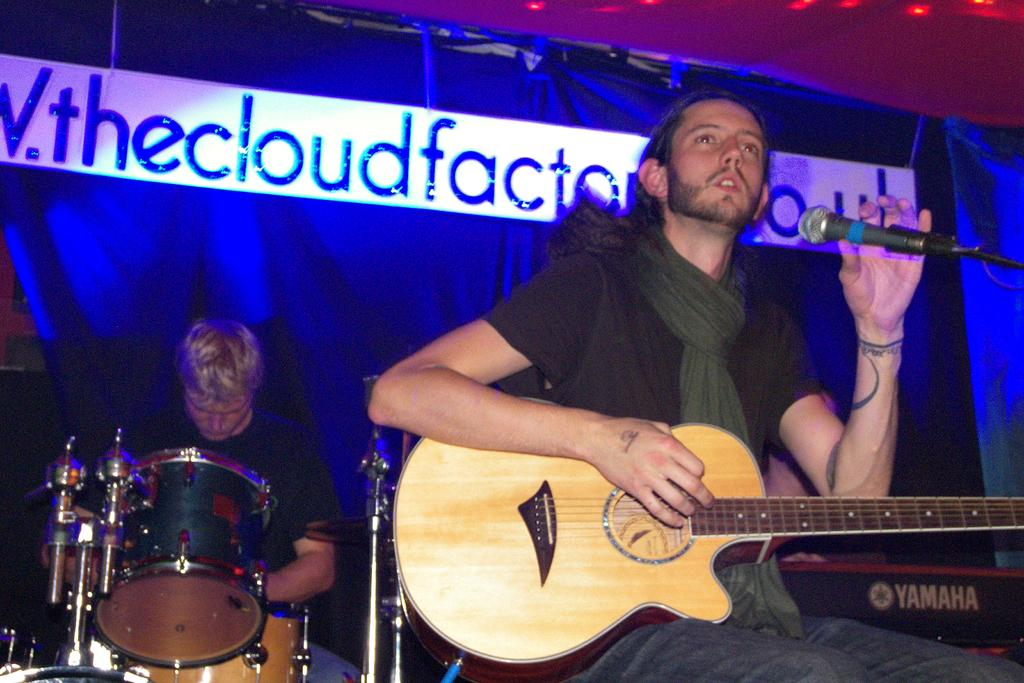What is the main subject of the image? There is a man in the image. What is the man holding in his left hand? The man is holding a microphone in his left hand. What is the man holding in his right hand? The man is holding a guitar in his right hand. Where is the kitten playing on the railway in the image? There is no kitten or railway present in the image; it features a man holding a microphone and a guitar. What rule is being enforced by the man in the image? There is no indication of any rule enforcement in the image; the man is simply holding a microphone and a guitar. 